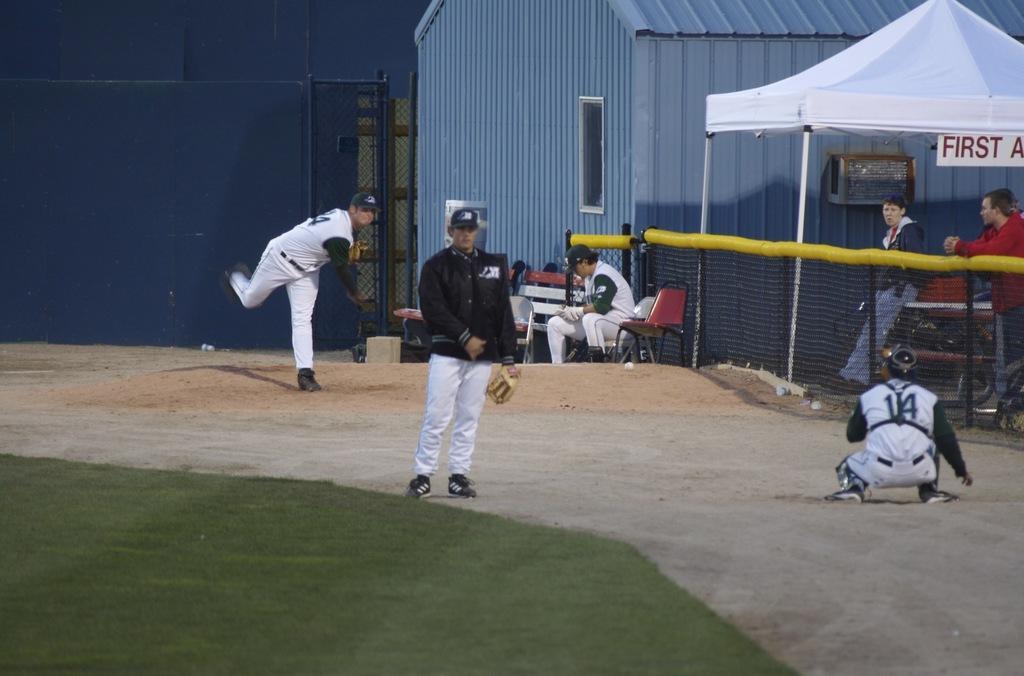Could you give a brief overview of what you see in this image? This image consists of some persons who are playing. There are some persons standing on the right side. There is a net on the right side. 